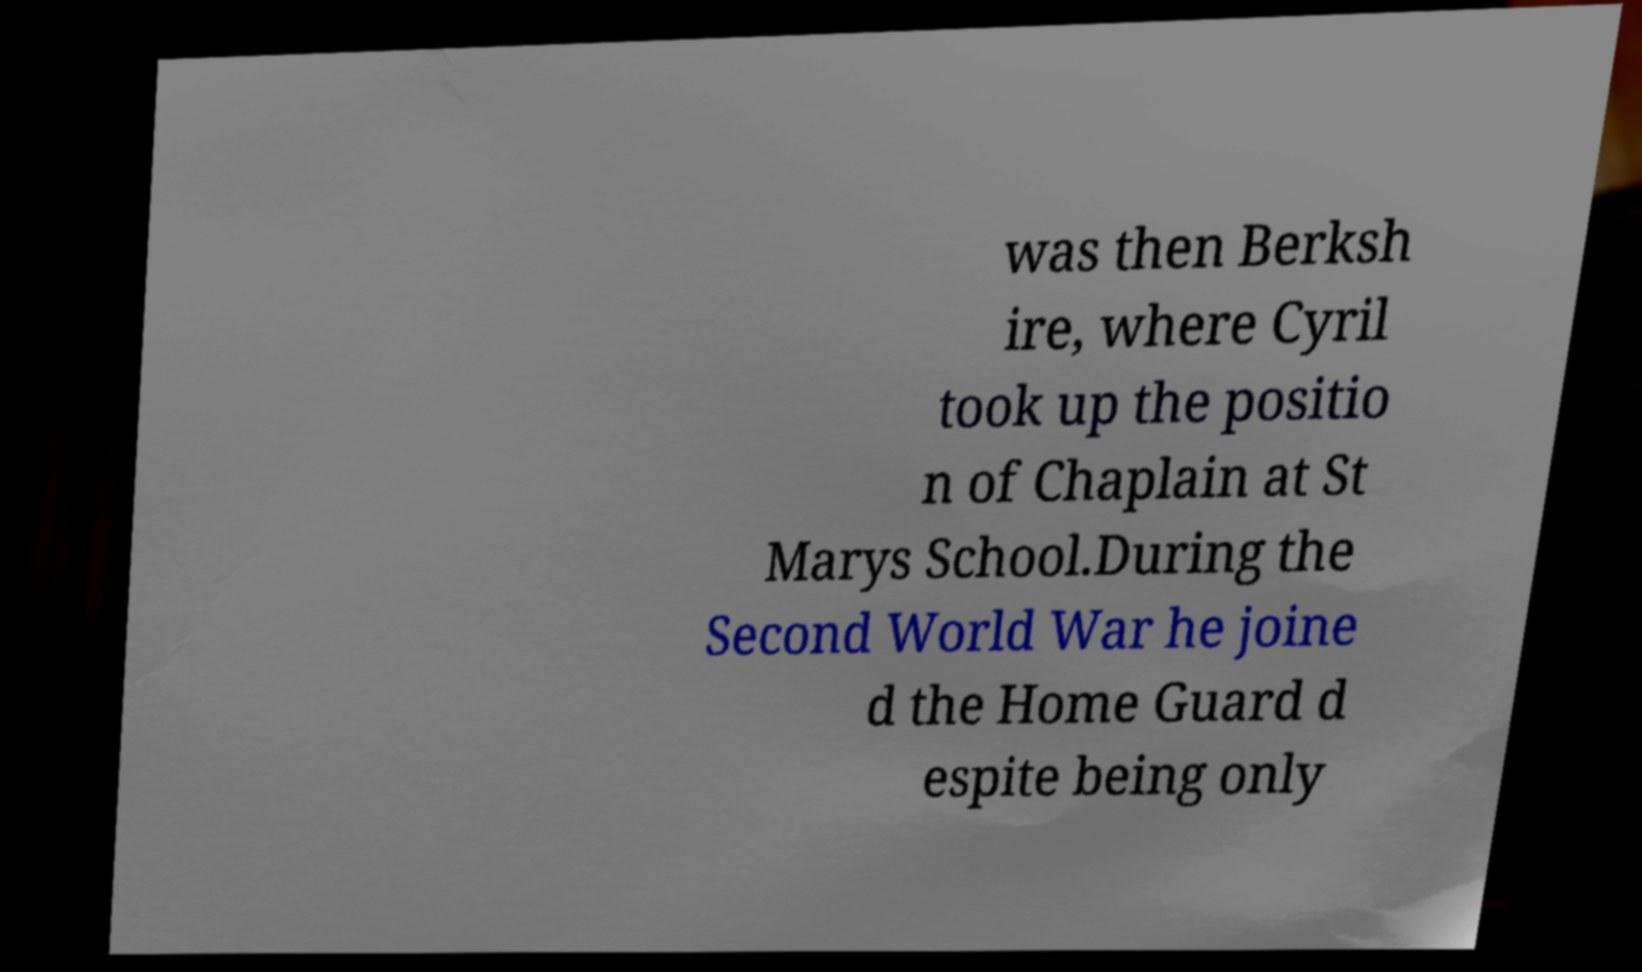Please identify and transcribe the text found in this image. was then Berksh ire, where Cyril took up the positio n of Chaplain at St Marys School.During the Second World War he joine d the Home Guard d espite being only 